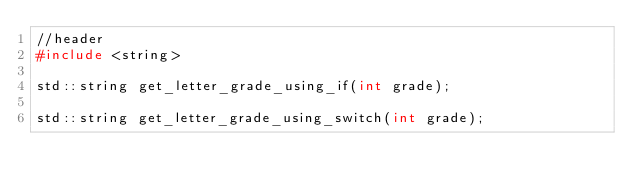Convert code to text. <code><loc_0><loc_0><loc_500><loc_500><_C_>//header
#include <string>

std::string get_letter_grade_using_if(int grade);

std::string get_letter_grade_using_switch(int grade);

</code> 